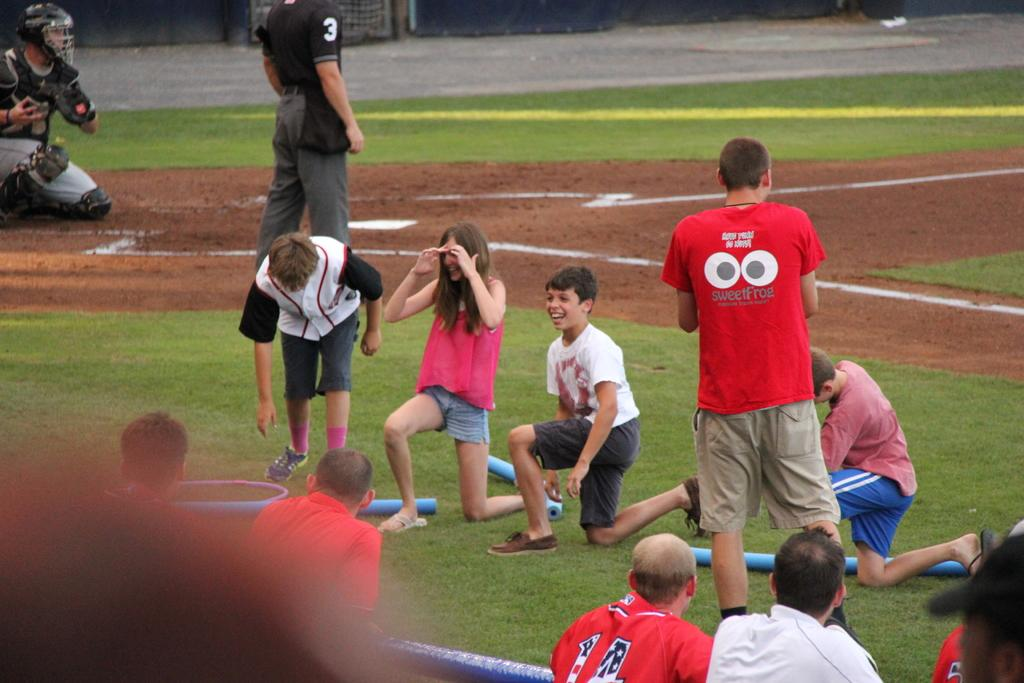How many people are in the image? There are people in the image, but the exact number is not specified. What are some of the positions the people are in? Some people are laying on their knees on the ground, while others are standing on the ground. Can you describe the actions of the people in the image? The actions of the people are not specified, but their positions suggest they might be participating in an activity or event. What type of dirt can be seen in the zoo committee meeting in the image? There is no mention of dirt, a zoo, or a committee meeting in the image. The image only shows people in various positions on the ground. 